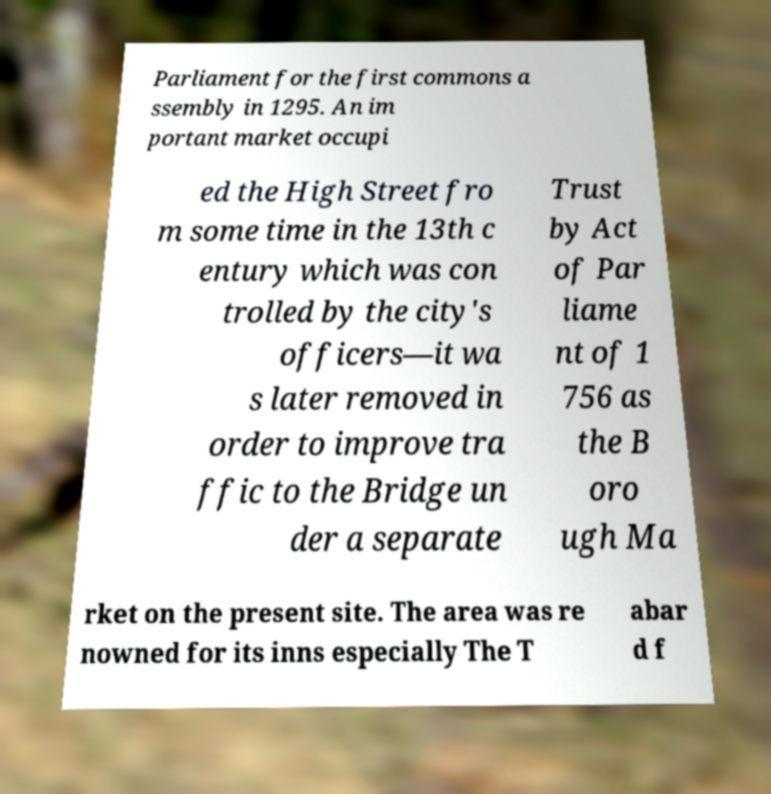Can you accurately transcribe the text from the provided image for me? Parliament for the first commons a ssembly in 1295. An im portant market occupi ed the High Street fro m some time in the 13th c entury which was con trolled by the city's officers—it wa s later removed in order to improve tra ffic to the Bridge un der a separate Trust by Act of Par liame nt of 1 756 as the B oro ugh Ma rket on the present site. The area was re nowned for its inns especially The T abar d f 